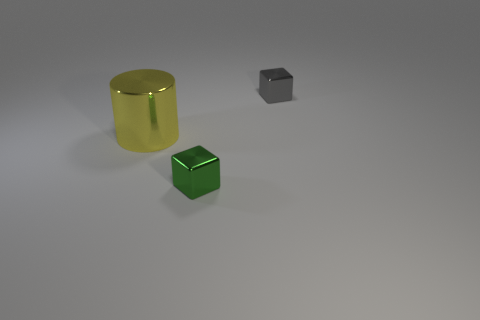What is the shape of the tiny metal object that is on the left side of the object that is behind the yellow cylinder?
Your answer should be very brief. Cube. How many other objects are the same color as the big thing?
Your response must be concise. 0. Do the small cube that is left of the gray metallic object and the small thing behind the small green shiny block have the same material?
Ensure brevity in your answer.  Yes. There is a metal thing that is to the left of the green block; how big is it?
Make the answer very short. Large. There is another tiny thing that is the same shape as the small gray thing; what material is it?
Ensure brevity in your answer.  Metal. Are there any other things that are the same size as the yellow cylinder?
Your answer should be very brief. No. What shape is the small metallic thing right of the small green cube?
Make the answer very short. Cube. How many other metal things are the same shape as the small green metallic object?
Your answer should be compact. 1. Is the number of metallic objects that are behind the green metallic thing the same as the number of small metallic objects in front of the small gray shiny thing?
Provide a short and direct response. No. Is there another block made of the same material as the small green cube?
Your answer should be compact. Yes. 